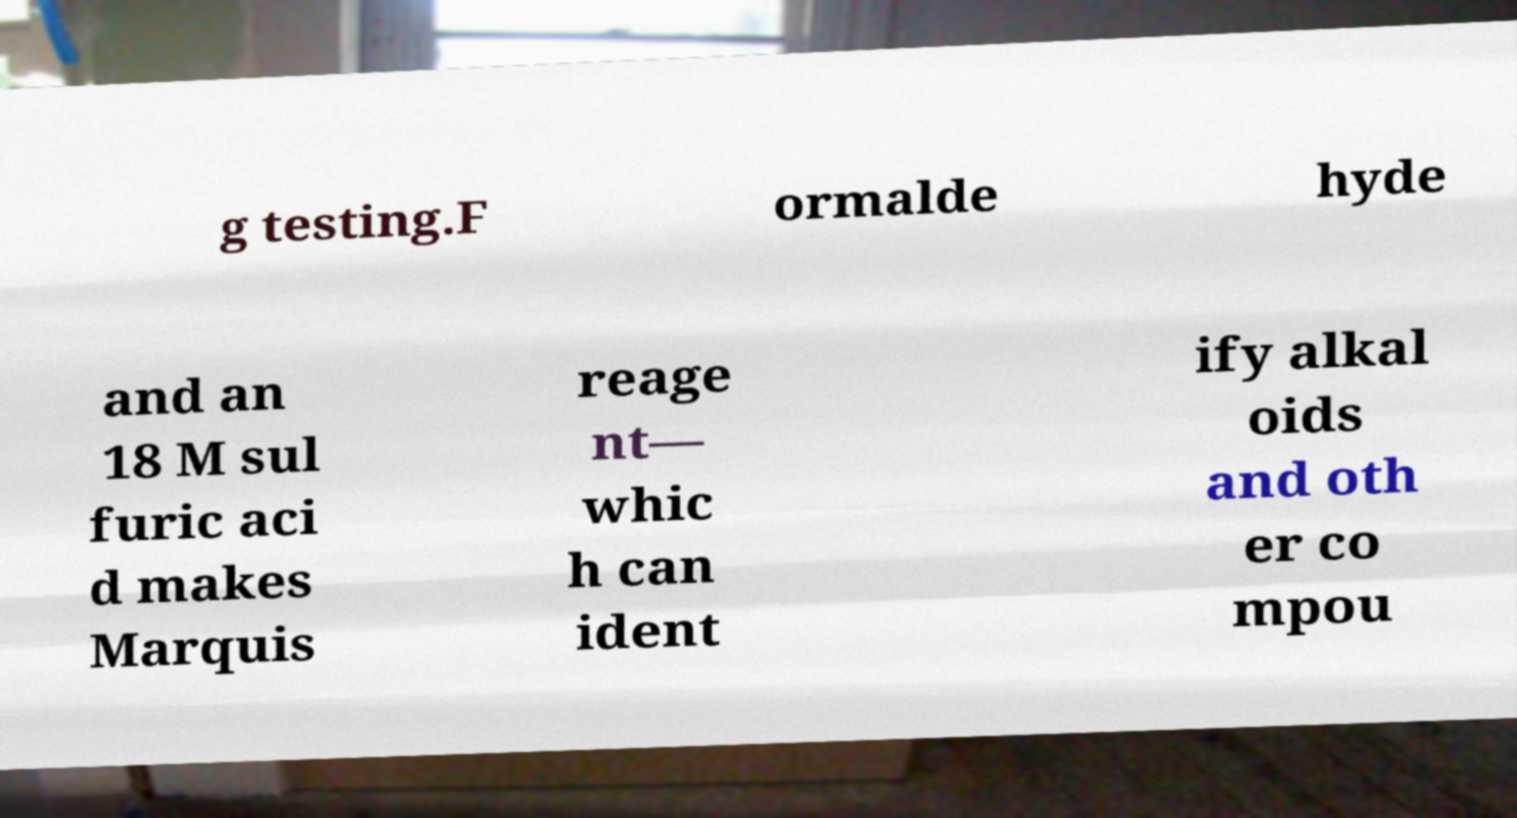For documentation purposes, I need the text within this image transcribed. Could you provide that? g testing.F ormalde hyde and an 18 M sul furic aci d makes Marquis reage nt— whic h can ident ify alkal oids and oth er co mpou 